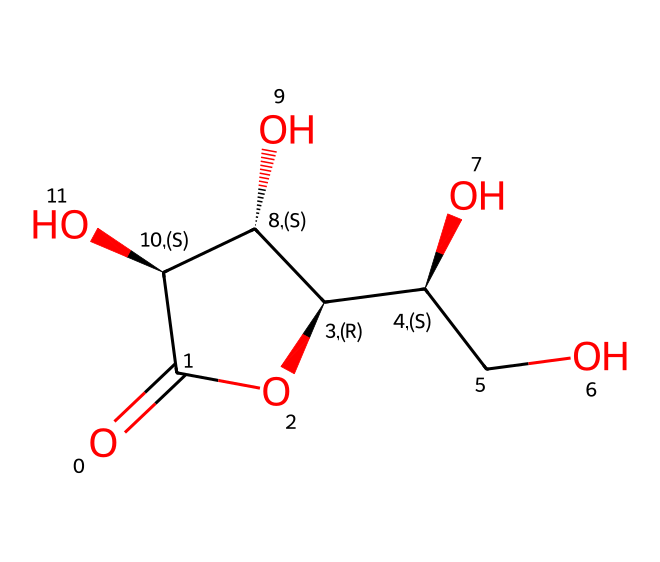What is the molecular formula of vitamin C represented? The SMILES notation indicates the presence of carbon (C), hydrogen (H), and oxygen (O) atoms. By decoding the SMILES string, we can count the atoms: 6 carbon atoms, 8 hydrogen atoms, and 6 oxygen atoms, leading to the molecular formula C6H8O6.
Answer: C6H8O6 How many hydroxyl groups are present in vitamin C? The structure includes multiple -OH (hydroxyl) groups. By examining the SMILES representation, we can identify three -OH groups attached to the carbon skeleton.
Answer: three Is vitamin C a water-soluble vitamin? Due to the presence of multiple hydroxyl (-OH) groups in the structure, it is likely to interact well with water, categorizing it as a water-soluble vitamin.
Answer: yes What is the type of functional groups present in vitamin C? The compound contains several hydroxyl (-OH) groups, as well as a ketone functional group (C=O), indicating that it has both alcohol and ketone functionalities.
Answer: alcohol, ketone Which chiral centers are in the structure of vitamin C? By examining the carbon atoms in the SMILES representation, we identify that there are two chiral centers where each carbon atoms bears four different substituents. These are marked by @ symbols in the SMILES; hence, the molecule is chiral and contains two chiral centers.
Answer: two What is the significance of vitamin C's structure in its function as an antioxidant? The structure's hydroxyl groups can donate hydrogen atoms to free radicals, neutralizing them. This capability is essential for its role as an antioxidant. Thus, the presence of these features in its structure illustrates why it functions effectively as an antioxidant.
Answer: antioxidant What role does the ketone group play in vitamin C's reactivity? The ketone group (C=O) enhances the reactivity of vitamin C by allowing it to participate in additional chemical reactions such as redox reactions, further contributing to its biological activity and effectiveness as a nutrient.
Answer: reactivity 